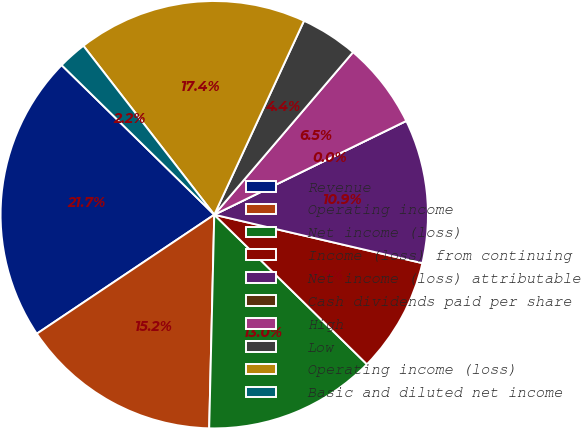Convert chart to OTSL. <chart><loc_0><loc_0><loc_500><loc_500><pie_chart><fcel>Revenue<fcel>Operating income<fcel>Net income (loss)<fcel>Income (loss) from continuing<fcel>Net income (loss) attributable<fcel>Cash dividends paid per share<fcel>High<fcel>Low<fcel>Operating income (loss)<fcel>Basic and diluted net income<nl><fcel>21.74%<fcel>15.22%<fcel>13.04%<fcel>8.7%<fcel>10.87%<fcel>0.0%<fcel>6.52%<fcel>4.35%<fcel>17.39%<fcel>2.17%<nl></chart> 